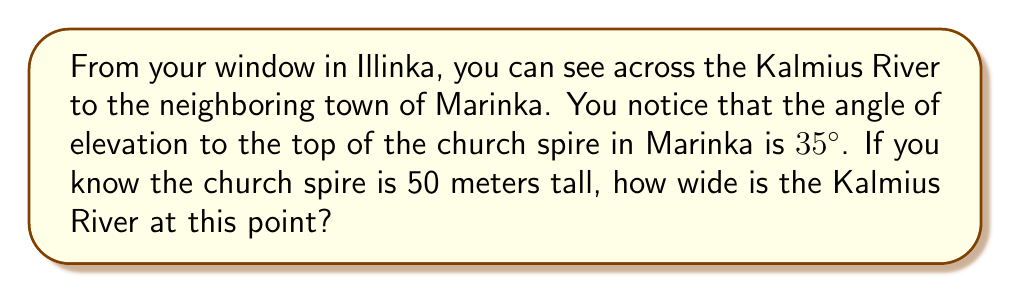Give your solution to this math problem. Let's approach this step-by-step using trigonometry:

1) First, let's visualize the problem:

[asy]
import geometry;

size(200);
pair A = (0,0), B = (200,0), C = (200,140);
draw(A--B--C--A);
draw((0,-10)--(200,-10),arrow=Arrow(TeXHead));
label("Kalmius River",(-10,-20),SW);
label("Church Spire",C,NE);
label("50 m",B+(10,70),E);
label("35°",A+(20,0),N);
label("x",B+(-100,-20),S);
[/asy]

2) We can see that this forms a right-angled triangle, where:
   - The width of the river is the base of the triangle
   - The height of the church spire is the opposite side
   - The angle of elevation is the angle between the base and the hypotenuse

3) We need to use the tangent function, as we know the opposite side and the angle, and we're looking for the adjacent side:

   $$\tan(\theta) = \frac{\text{opposite}}{\text{adjacent}}$$

4) Plugging in our known values:

   $$\tan(35°) = \frac{50}{\text{river width}}$$

5) Let's call the river width $x$. We can rewrite the equation as:

   $$\tan(35°) = \frac{50}{x}$$

6) To solve for $x$, we multiply both sides by $x$:

   $$x \cdot \tan(35°) = 50$$

7) Then divide both sides by $\tan(35°)$:

   $$x = \frac{50}{\tan(35°)}$$

8) Now we can calculate this:
   
   $$x = \frac{50}{\tan(35°)} \approx 71.41 \text{ meters}$$
Answer: 71.41 meters 